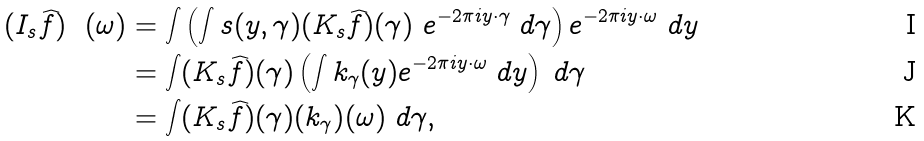Convert formula to latex. <formula><loc_0><loc_0><loc_500><loc_500>( I _ { s } \widehat { f } ) \ \ ( \omega ) & = \int \left ( \int s ( y , \gamma ) ( K _ { s } \widehat { f } ) ( \gamma ) \ e ^ { - 2 \pi i y \cdot \gamma } \ d \gamma \right ) e ^ { - 2 \pi i y \cdot \omega } \ d y \\ & = \int ( K _ { s } \widehat { f } ) ( \gamma ) \left ( \int k _ { \gamma } ( y ) e ^ { - 2 \pi i y \cdot \omega } \ d y \right ) \ d \gamma \\ & = \int ( K _ { s } \widehat { f } ) ( \gamma ) ( k _ { \gamma } ) ^ { } ( \omega ) \ d \gamma ,</formula> 